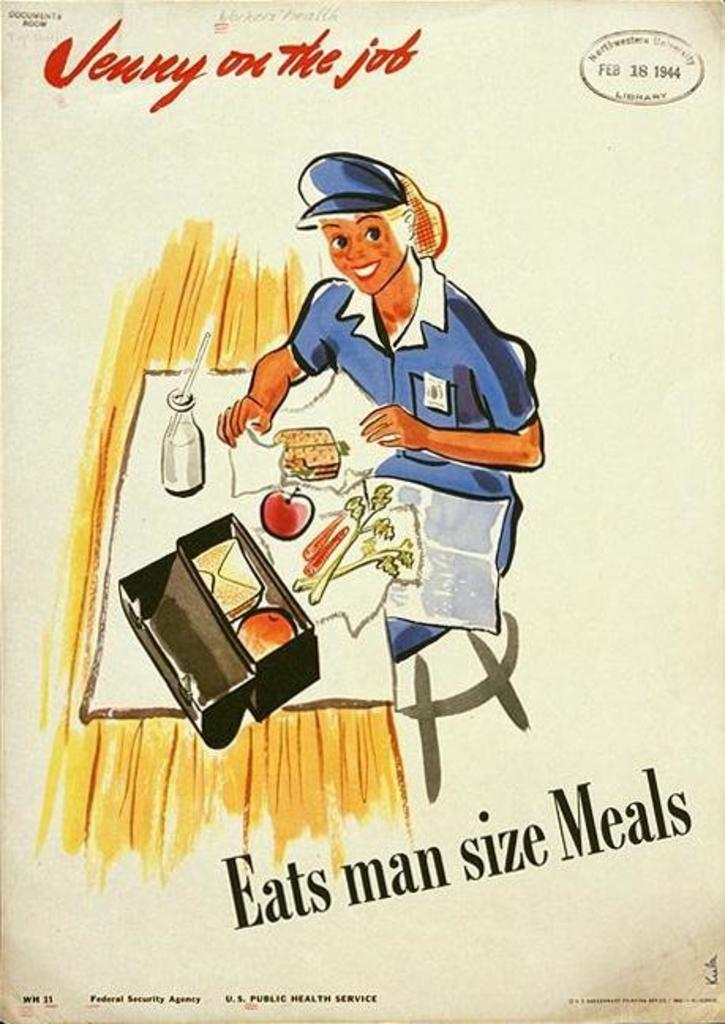<image>
Offer a succinct explanation of the picture presented. A book titled "Jenny on the job" with a date stamp of Feb 18 1944. 